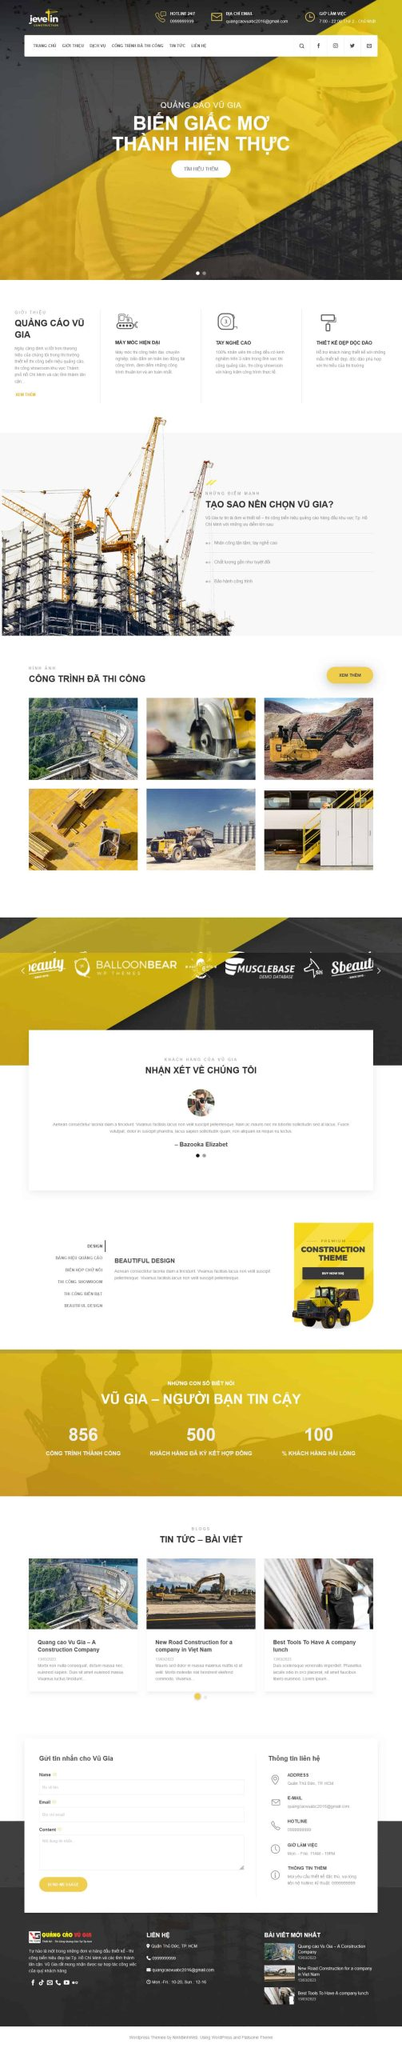Viết một bài viết giới thiệu giao diện website này của DPS MEDIA bao gồm ngành nghề, kiểu dáng, màu sắc, tính năng, bố cục,...Nhưng không nhắc lại liên kết hình ảnh trong bài viết.
 DPS MEDIA là một công ty chuyên cung cấp dịch vụ quảng cáo và truyền thông. Giao diện website của DPS MEDIA được thiết kế với phong cách hiện đại, chuyên nghiệp, phù hợp với lĩnh vực xây dựng và quảng cáo.

**Ngành nghề:**
Trang web tập trung vào lĩnh vực quảng cáo xây dựng, với các dịch vụ như quảng cáo ngoài trời, thiết kế và thi công các công trình xây dựng.

**Kiểu dáng và màu sắc:**
Giao diện website sử dụng tông màu chủ đạo là vàng và trắng, kết hợp với các dải màu đen để tạo ra sự tương phản và điểm nhấn. Màu vàng tượng trưng cho sự năng động, sáng tạo và nhiệt huyết, trong khi màu trắng mang lại cảm giác sạch sẽ, tinh tế và chuyên nghiệp.

**Tính năng:**
Website của DPS MEDIA được trang bị nhiều tính năng hữu ích như:
- Thanh tìm kiếm ở phía trên cùng, giúp người dùng dễ dàng tìm kiếm thông tin.
- Menu điều hướng rõ ràng với các mục như trang chủ, giới thiệu, dịch vụ, công trình đã thi công, tin tức và liên hệ.
- Phần trình bày dịch vụ chi tiết, giúp khách hàng dễ dàng hiểu rõ về các dịch vụ mà DPS MEDIA cung cấp.
- Mục công trình đã thi công với hình ảnh chất lượng cao, thể hiện rõ ràng các dự án mà công ty đã thực hiện.
- Phần đánh giá từ khách hàng, tạo sự tin tưởng và uy tín cho công ty.

**Bố cục:**
Bố cục của trang web được sắp xếp một cách khoa học và hợp lý, giúp người dùng dễ dàng theo dõi và tìm kiếm thông tin:
- Phần đầu trang (header) chứa logo, thông tin liên hệ và thanh tìm kiếm.
- Phần giữa trang (body) bao gồm các mục giới thiệu dịch vụ, công trình đã thi công, đánh giá từ khách hàng và các bài viết tin tức.
- Phần chân trang (footer) chứa thông tin liên hệ, liên kết mạng xã hội và các bài viết mới nhất.

**Tổng kết:**
Giao diện website của DPS MEDIA là một sự kết hợp hoàn hảo giữa tính thẩm mỹ và tính năng, mang lại trải nghiệm người dùng tốt nhất. Với bố cục rõ ràng, màu sắc hài hòa và các tính năng tiện ích, trang web không chỉ giúp khách hàng dễ dàng tìm kiếm thông tin mà còn thể hiện được sự chuyên nghiệp và uy tín của công ty. 